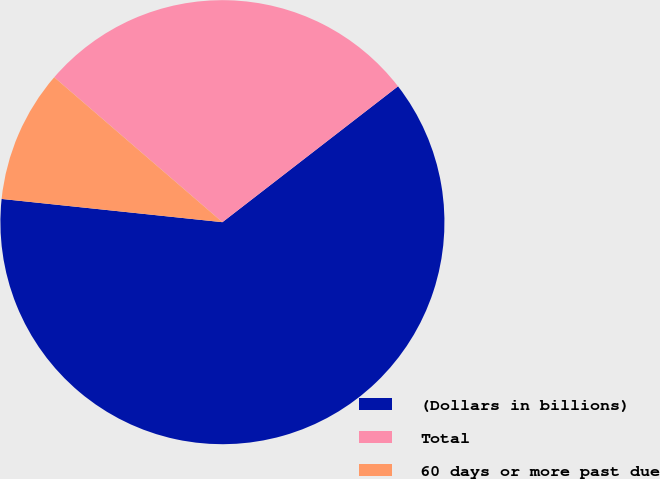<chart> <loc_0><loc_0><loc_500><loc_500><pie_chart><fcel>(Dollars in billions)<fcel>Total<fcel>60 days or more past due<nl><fcel>62.15%<fcel>28.2%<fcel>9.65%<nl></chart> 